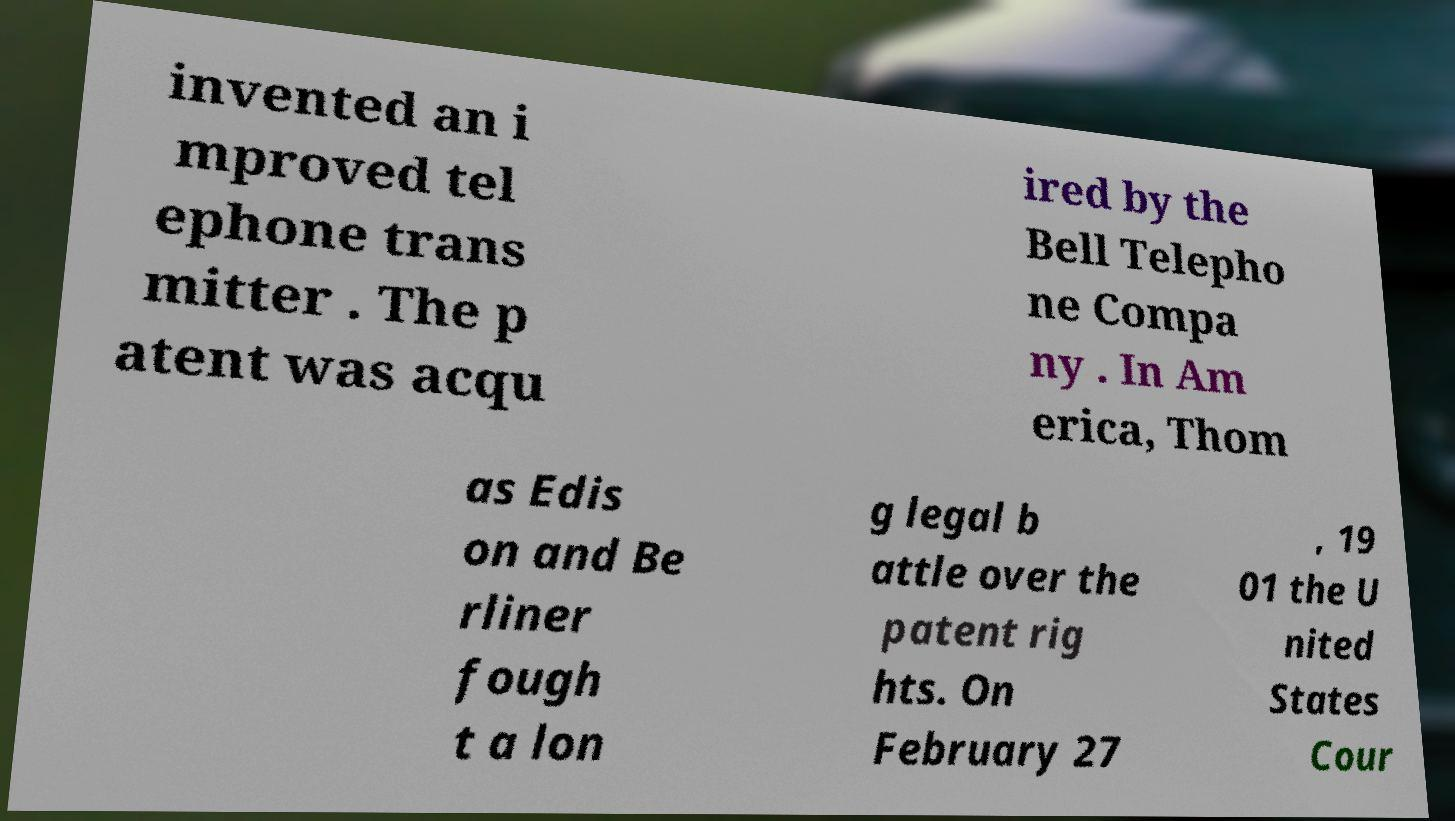Could you assist in decoding the text presented in this image and type it out clearly? invented an i mproved tel ephone trans mitter . The p atent was acqu ired by the Bell Telepho ne Compa ny . In Am erica, Thom as Edis on and Be rliner fough t a lon g legal b attle over the patent rig hts. On February 27 , 19 01 the U nited States Cour 